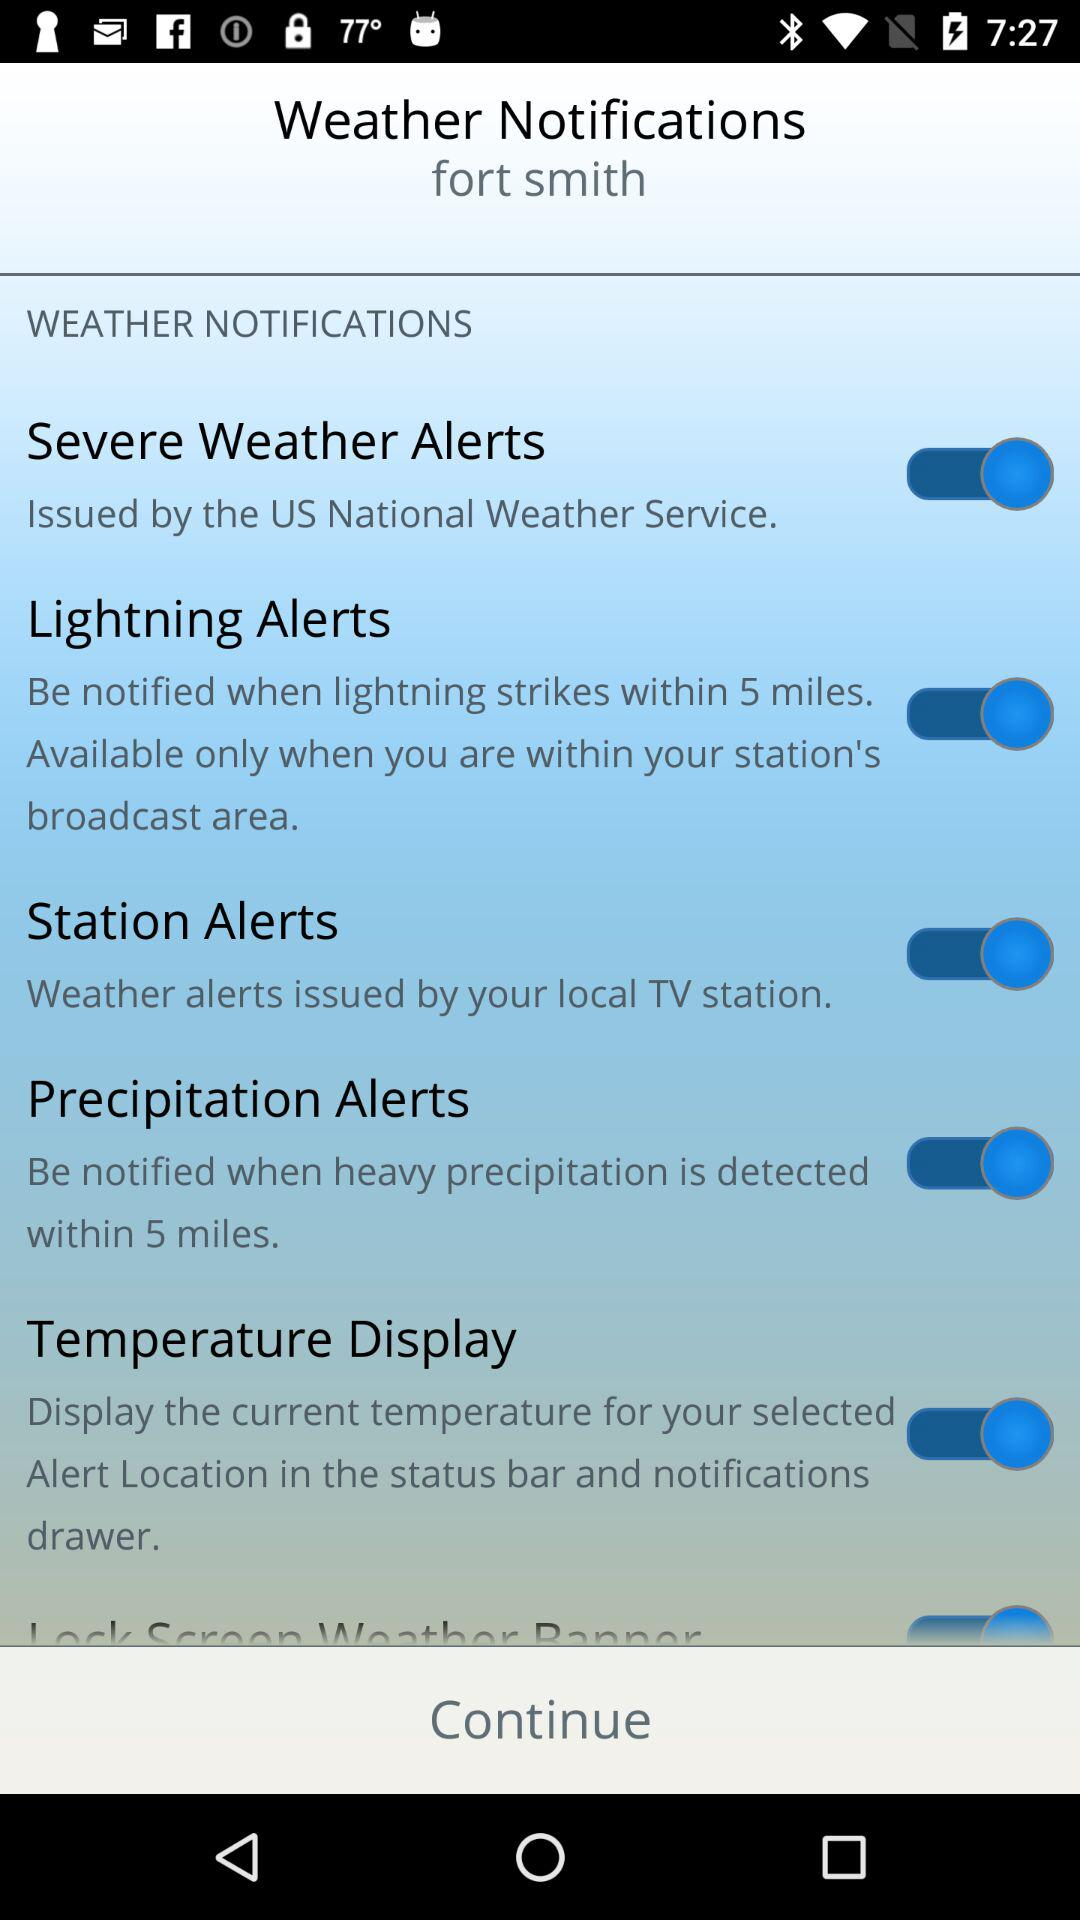What is the status of the "Precipitation Alerts"? The status is "on". 